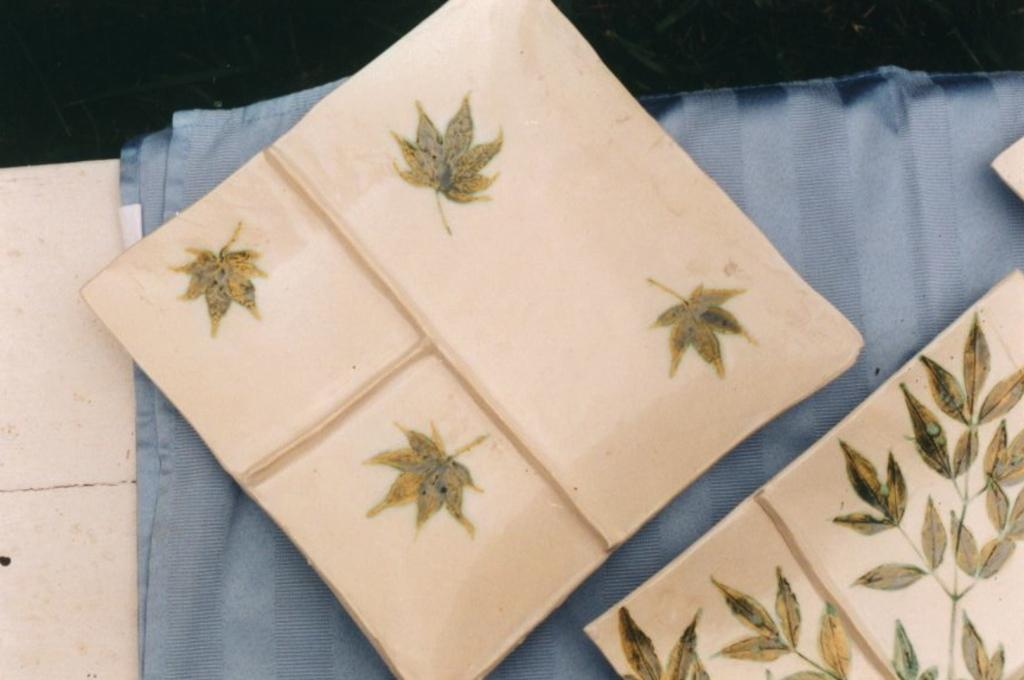What is the main subject of the image? The main subject of the image is an object with clothes on it. Can you describe the object in more detail? Unfortunately, the provided facts do not give any additional information about the object. What type of clothes can be seen on the object? The facts do not specify the type of clothes on the object. What type of pear is hanging from the clothes in the image? There is no pear present in the image. What kind of jewel is attached to the clothes in the image? There is no jewel present in the image. 